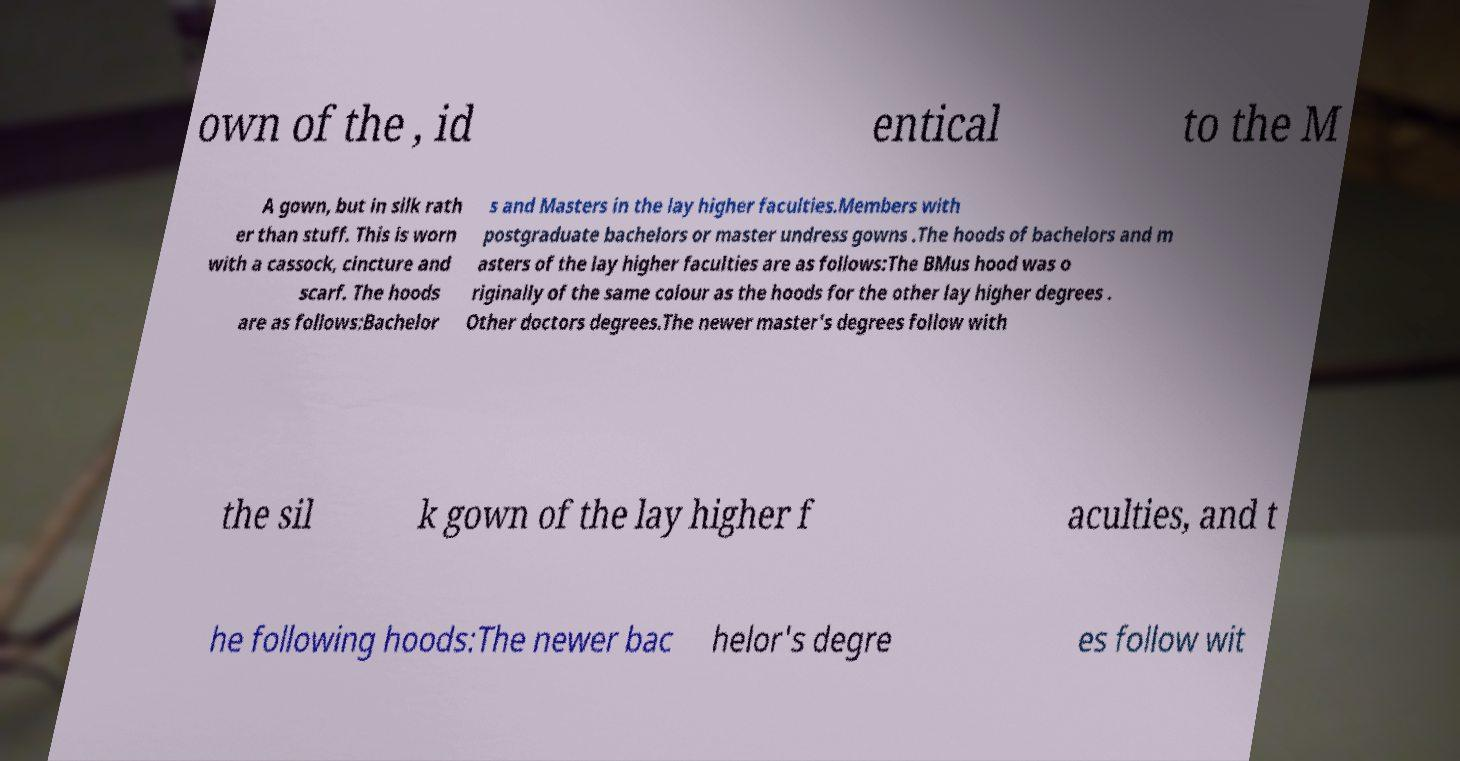Could you extract and type out the text from this image? own of the , id entical to the M A gown, but in silk rath er than stuff. This is worn with a cassock, cincture and scarf. The hoods are as follows:Bachelor s and Masters in the lay higher faculties.Members with postgraduate bachelors or master undress gowns .The hoods of bachelors and m asters of the lay higher faculties are as follows:The BMus hood was o riginally of the same colour as the hoods for the other lay higher degrees . Other doctors degrees.The newer master's degrees follow with the sil k gown of the lay higher f aculties, and t he following hoods:The newer bac helor's degre es follow wit 